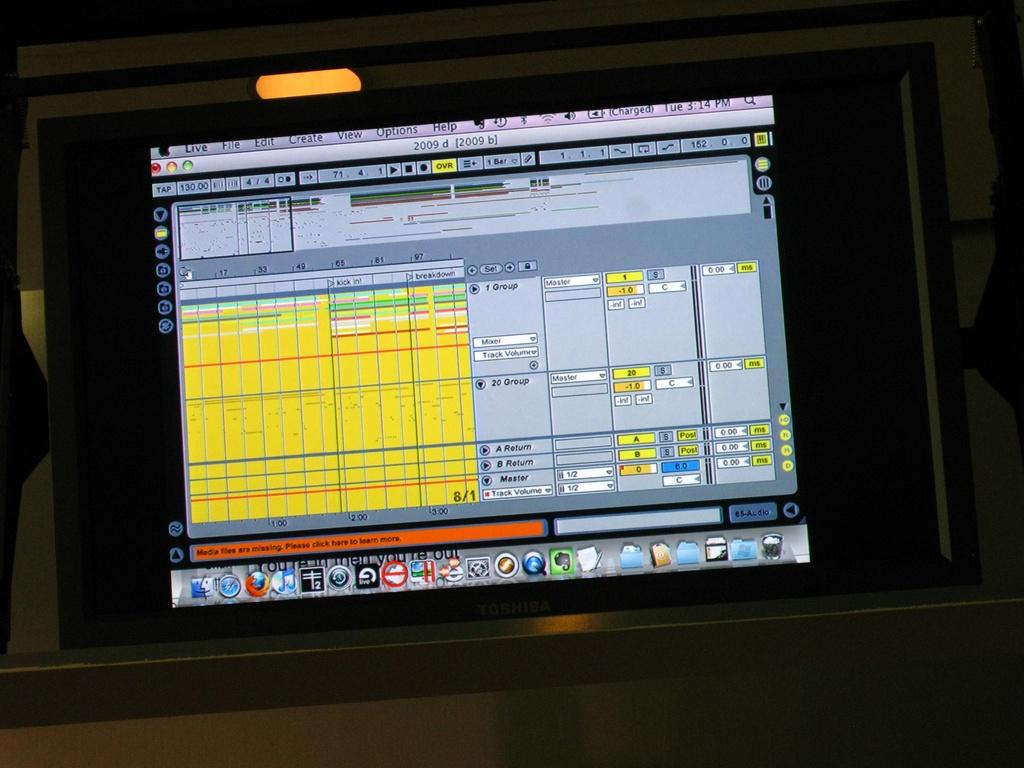<image>
Write a terse but informative summary of the picture. a screen with the word live in the top left corner 